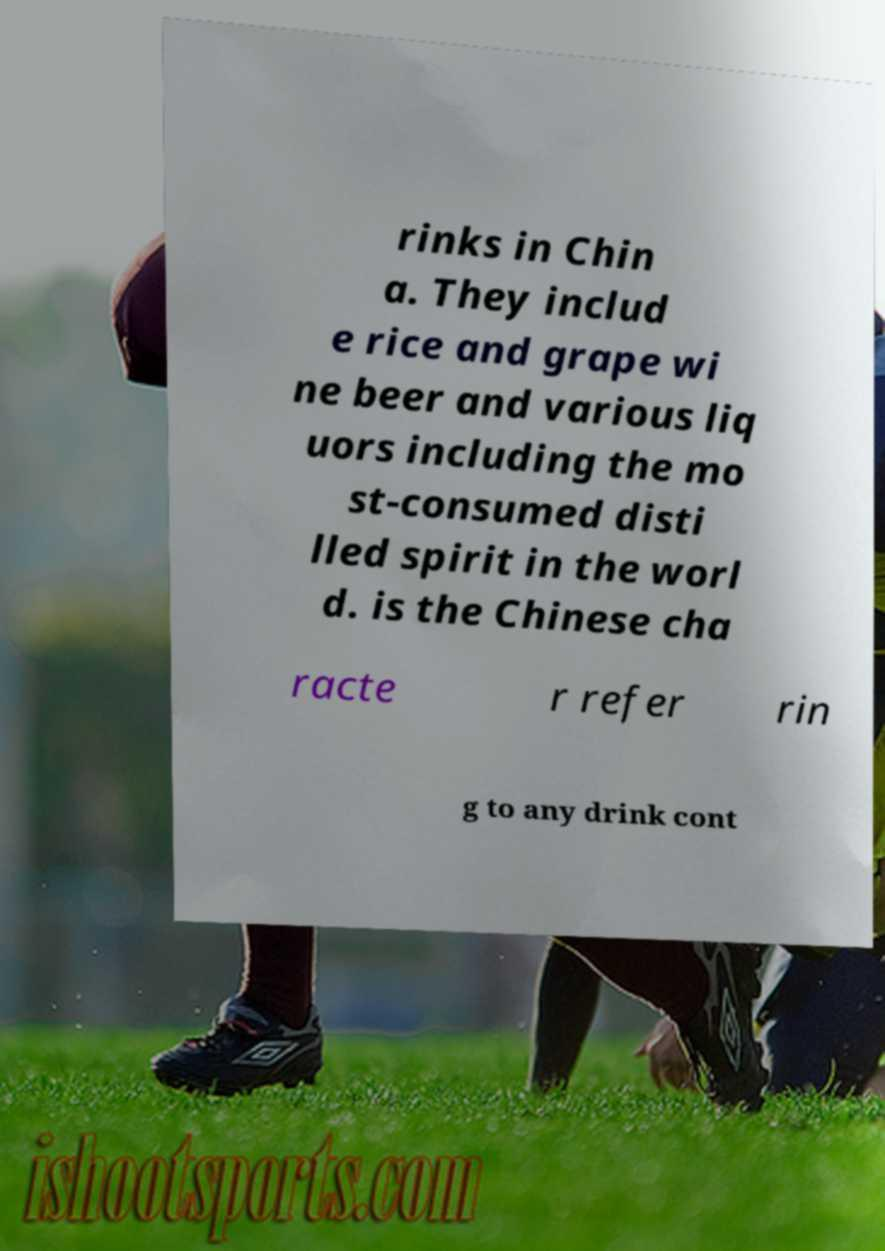I need the written content from this picture converted into text. Can you do that? rinks in Chin a. They includ e rice and grape wi ne beer and various liq uors including the mo st-consumed disti lled spirit in the worl d. is the Chinese cha racte r refer rin g to any drink cont 